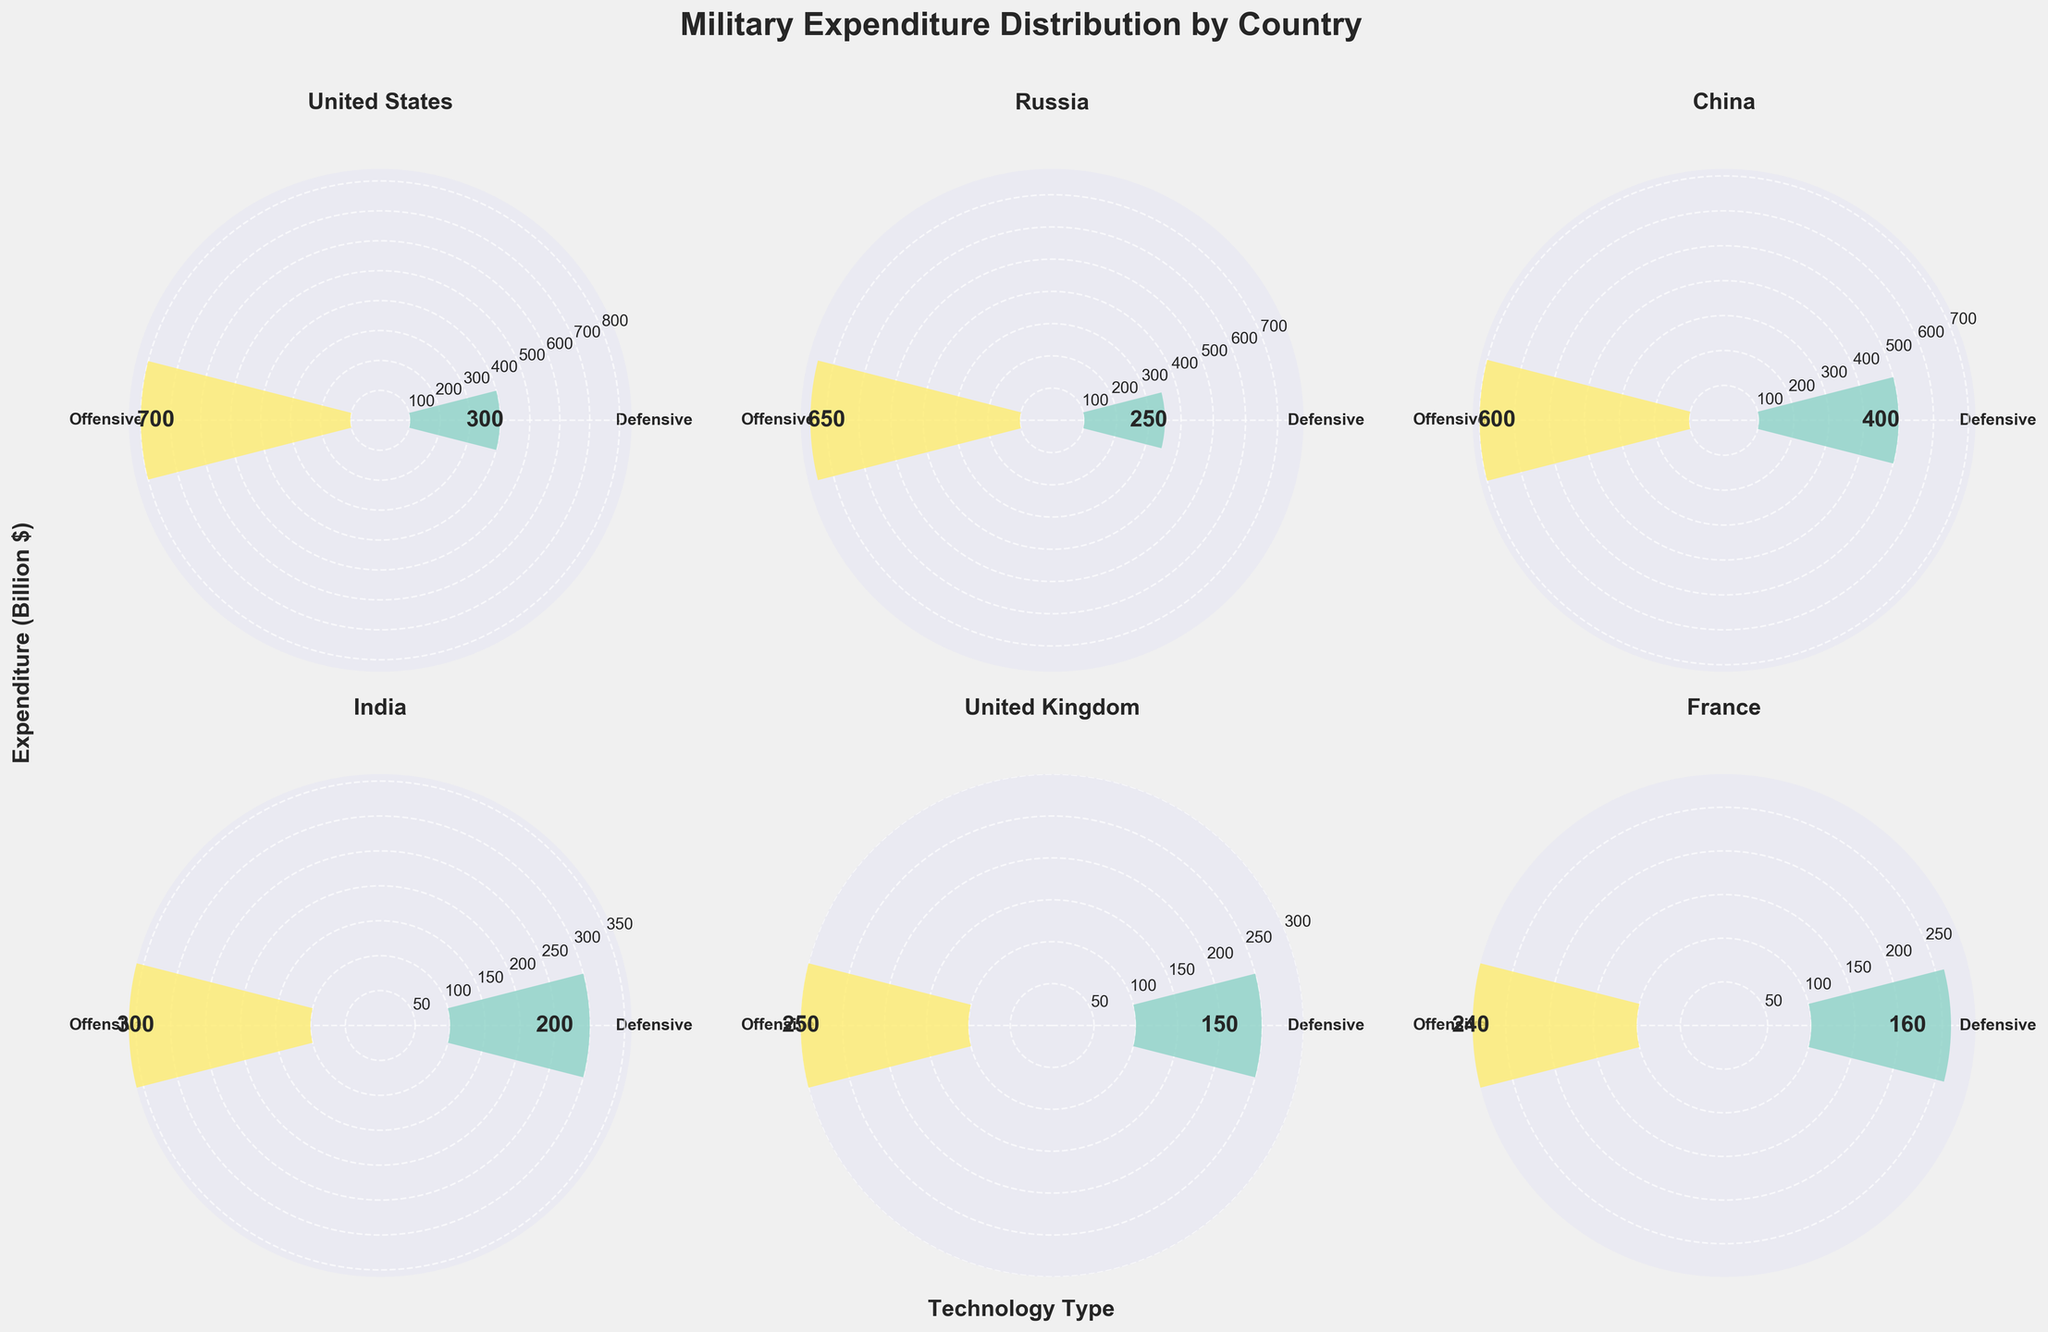What is the main title of the figure? The main title is displayed at the top of the figure in a large and bold font. It indicates the overall subject of the visualization, which in this case is mentioned at the top.
Answer: Military Expenditure Distribution by Country Which country spends the most on defensive technologies? By examining the height of the defensive expenditure bars, we can identify the country with the highest spending on defensive technologies.
Answer: China What are the total military expenditures (defensive + offensive) for the United States? Add the defensive and offensive expenditure values for the United States: 300 + 700.
Answer: 1000 Which country has the smallest difference between its offensive and defensive expenditures? Calculate the differences for each country and compare them: United States (700 - 300), Russia (650 - 250), China (600 - 400), India (300 - 200), United Kingdom (250 - 150), France (240 - 160), Germany (210 - 140), Japan (190 - 130). The smallest difference is for Japan (190 - 130).
Answer: Japan How does Germany's offensive expenditure compare to India's offensive expenditure? Compare the height of the offensive expenditure bars for Germany and India. Germany's offensive bar is slightly lower than India's.
Answer: Germany's offensive expenditure is less than India's What is the average expenditure on defensive technologies across all shown countries? Sum the defensive expenditures of all shown countries (300 + 250 + 400 + 200 + 150 + 160 + 140 + 130) and divide by the number of countries. (1730 / 8)
Answer: 216.25 How do the expenditures on defensive and offensive technologies for France compare? Compare the heights of the defensive and offensive bars for France.
Answer: France spends more on offensive technologies than defensive ones Which country has the highest total military expenditure? Sum the defensive and offensive expenditures for each country and compare: United States (1000), Russia (900), China (1000), India (500), United Kingdom (400), France (400), Germany (350), Japan (320). The United States and China both have the highest total expenditure.
Answer: United States and China What is the ratio of defensive to offensive expenditures for Russia? Divide the defensive expenditure by the offensive expenditure for Russia: 250 / 650.
Answer: 0.38 